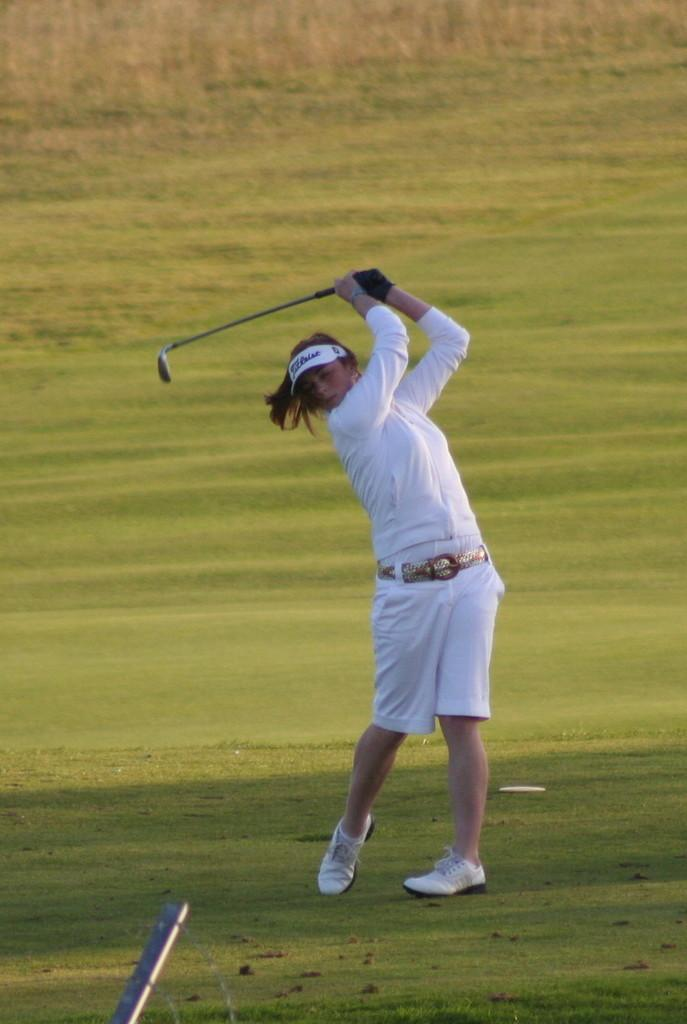Who is the main subject in the image? There is a girl in the image. What activity is the girl engaged in? The girl is playing golf. Where is the golf being played? The golf is being played on the ground. What type of cub can be seen playing with the golf ball in the image? There is no cub present in the image, and the girl is the one playing golf. 